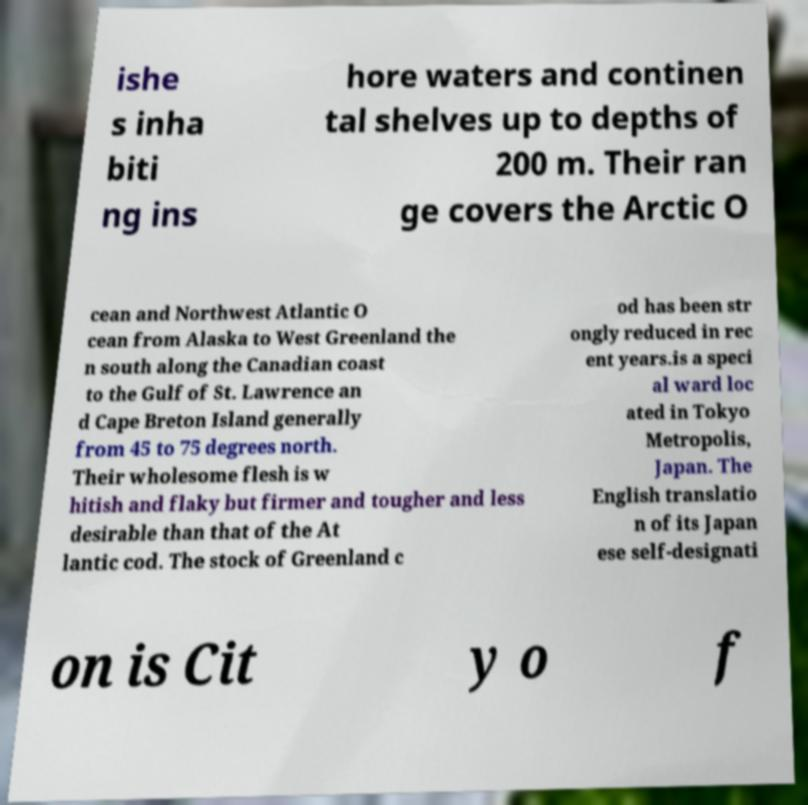For documentation purposes, I need the text within this image transcribed. Could you provide that? ishe s inha biti ng ins hore waters and continen tal shelves up to depths of 200 m. Their ran ge covers the Arctic O cean and Northwest Atlantic O cean from Alaska to West Greenland the n south along the Canadian coast to the Gulf of St. Lawrence an d Cape Breton Island generally from 45 to 75 degrees north. Their wholesome flesh is w hitish and flaky but firmer and tougher and less desirable than that of the At lantic cod. The stock of Greenland c od has been str ongly reduced in rec ent years.is a speci al ward loc ated in Tokyo Metropolis, Japan. The English translatio n of its Japan ese self-designati on is Cit y o f 